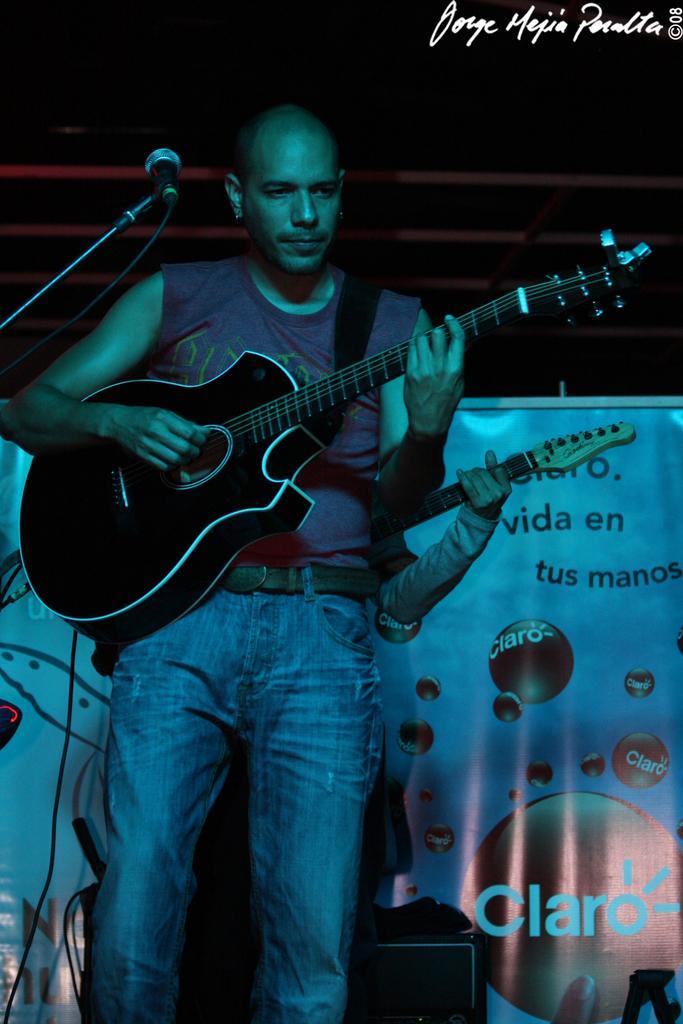Could you give a brief overview of what you see in this image? In this image in front there is a person holding the guitar. In front of him there is a mike. Behind him there is another person holding the guitar. In the background of the image there is a banner. In front of the banner there is some object. There is some text on the top right of the image. 